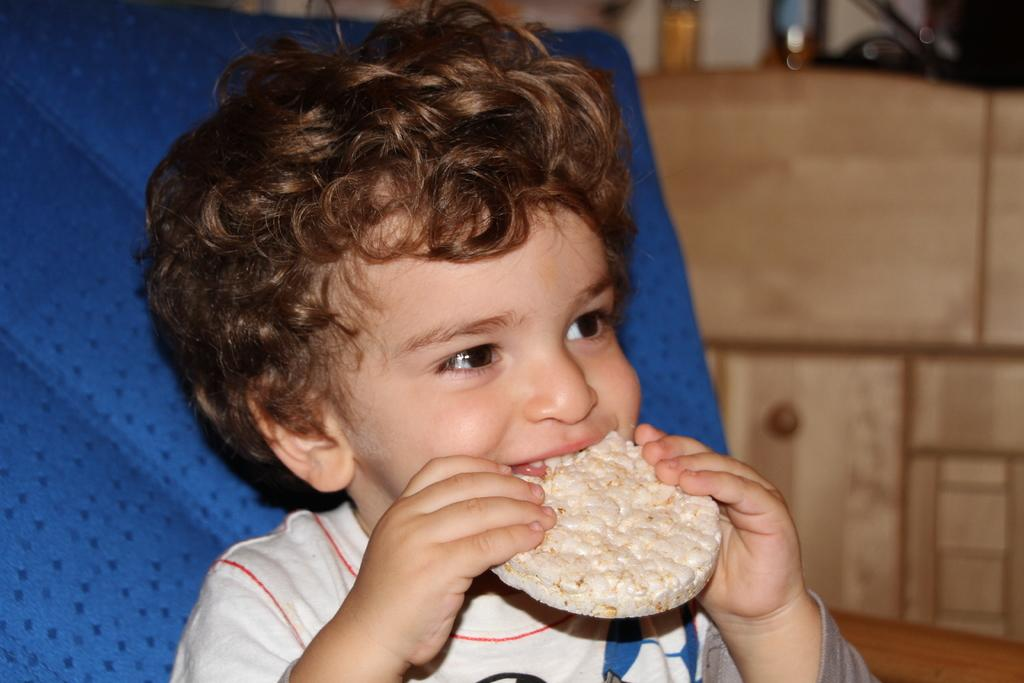Who is the main subject in the image? There is a little boy in the image. What is the boy doing in the image? The boy is eating something. Where is the boy sitting in the image? The boy is sitting on a couch. In which direction is the boy looking in the image? The boy is looking to the right side of the image. How would you describe the background of the image? The background of the image is blurred. What is the title of the book the boy is reading in the image? There is no book present in the image, and the boy is eating something, not reading. 